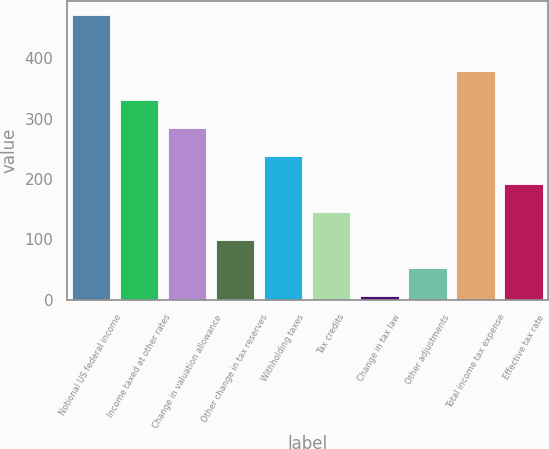<chart> <loc_0><loc_0><loc_500><loc_500><bar_chart><fcel>Notional US federal income<fcel>Income taxed at other rates<fcel>Change in valuation allowance<fcel>Other change in tax reserves<fcel>Withholding taxes<fcel>Tax credits<fcel>Change in tax law<fcel>Other adjustments<fcel>Total income tax expense<fcel>Effective tax rate<nl><fcel>471<fcel>331.5<fcel>285<fcel>99<fcel>238.5<fcel>145.5<fcel>6<fcel>52.5<fcel>378<fcel>192<nl></chart> 